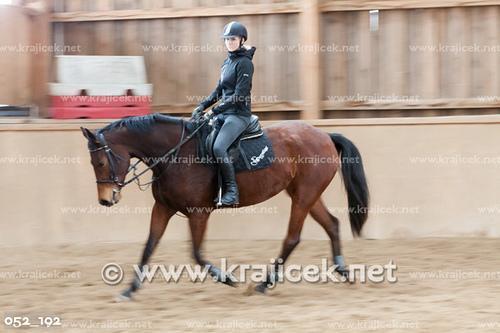How many people are in the picture?
Give a very brief answer. 1. 